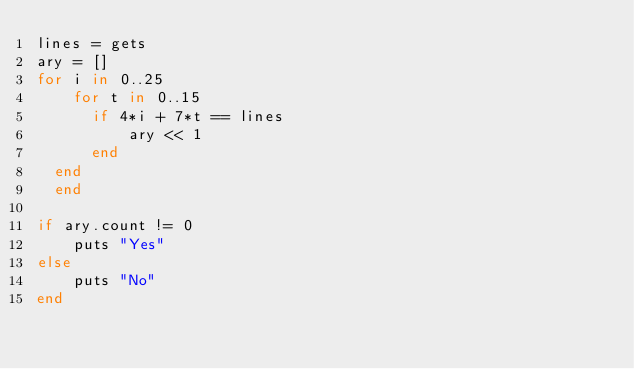Convert code to text. <code><loc_0><loc_0><loc_500><loc_500><_Ruby_>lines = gets
ary = []
for i in 0..25
    for t in 0..15
      if 4*i + 7*t == lines
          ary << 1
      end 
  end
  end

if ary.count != 0
    puts "Yes"
else
    puts "No"
end</code> 